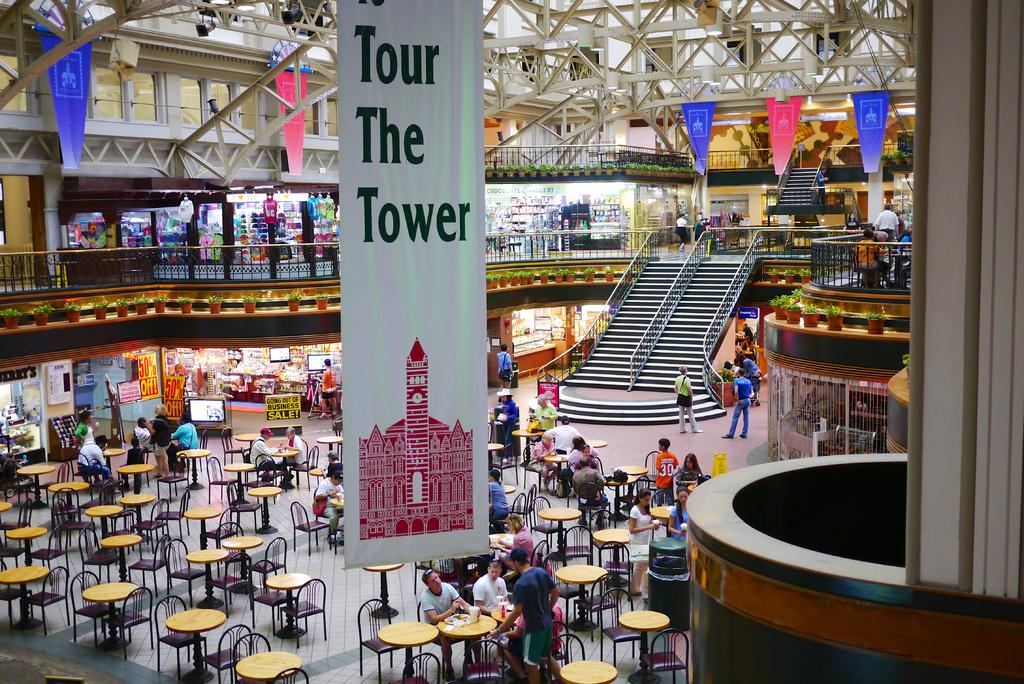<image>
Present a compact description of the photo's key features. A banner that reads "Tour The Tower" hangs above a large restaurant area in the mall 